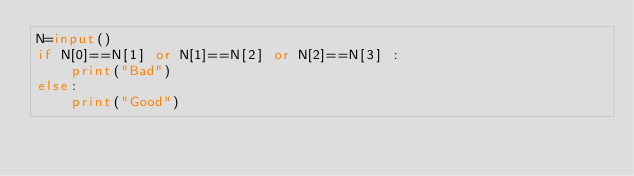Convert code to text. <code><loc_0><loc_0><loc_500><loc_500><_Python_>N=input()
if N[0]==N[1] or N[1]==N[2] or N[2]==N[3] :
    print("Bad")
else:
    print("Good")</code> 